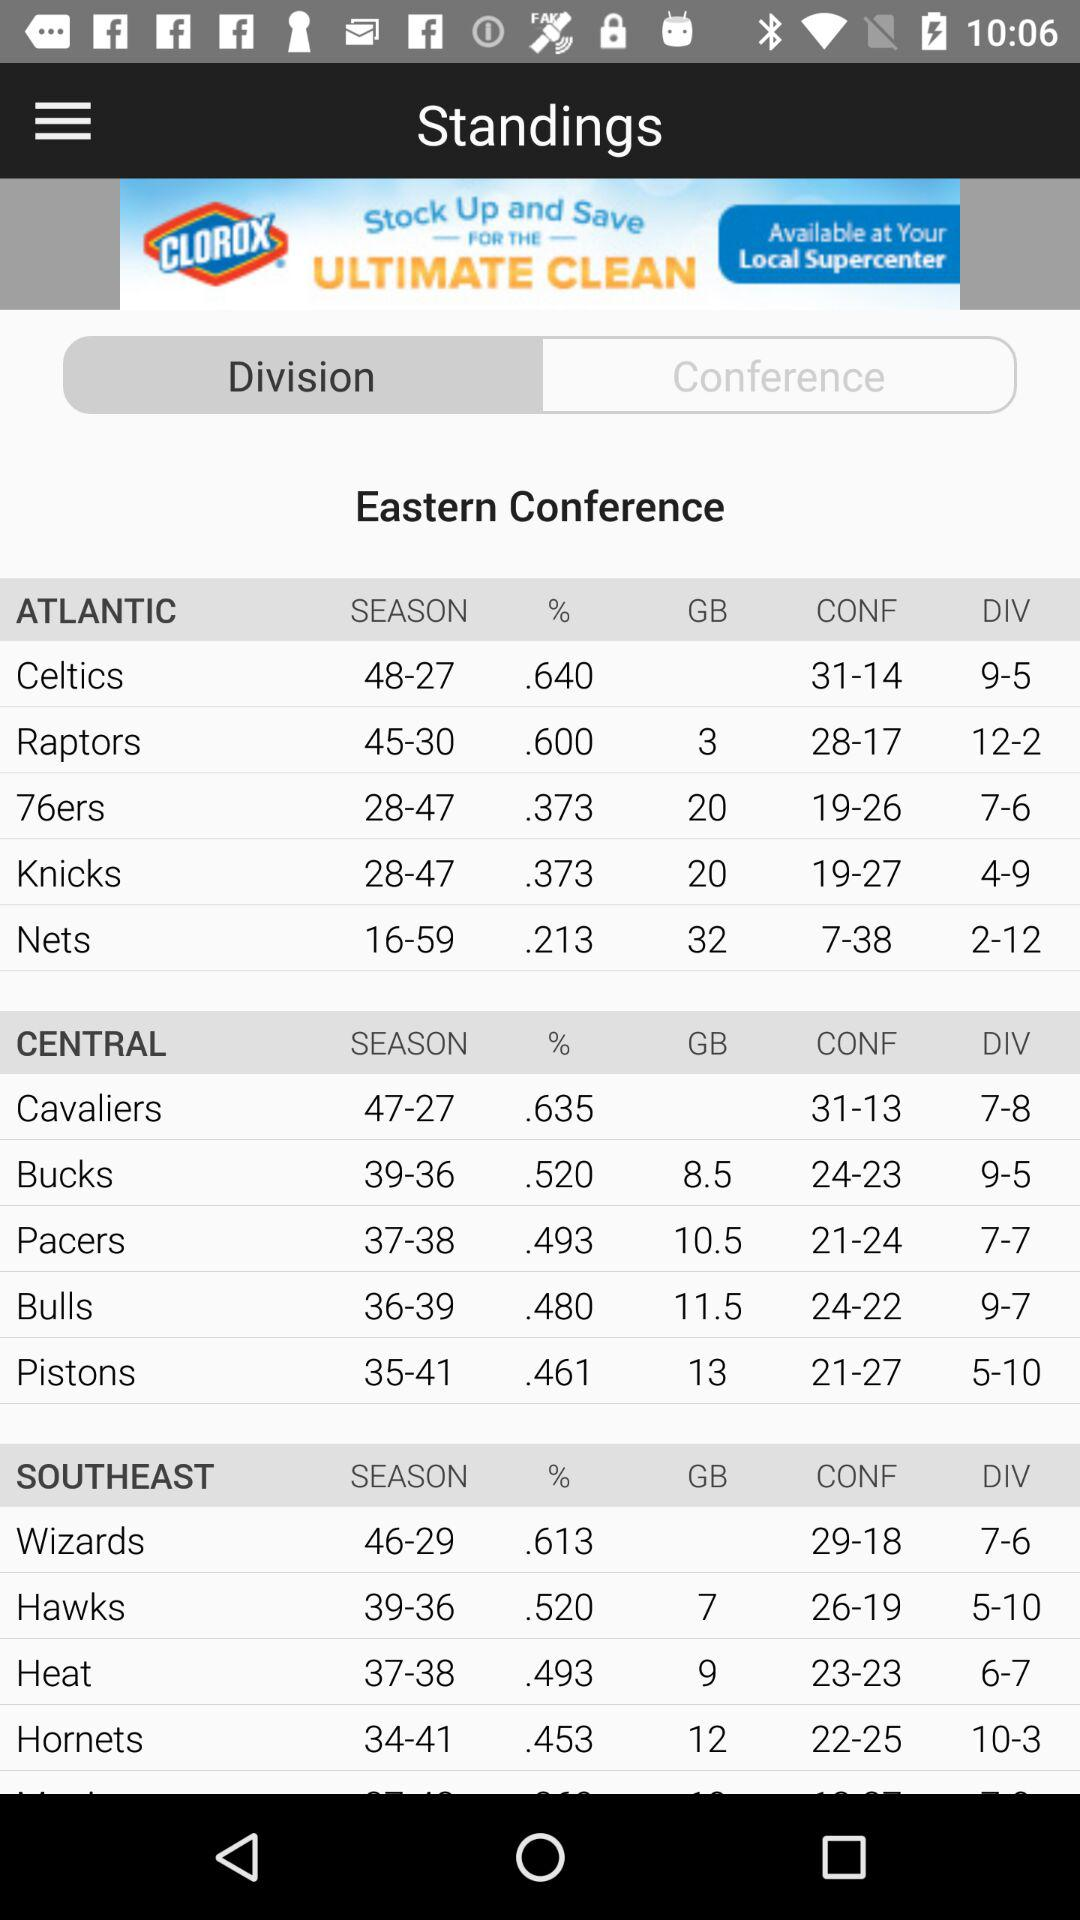Which team has the worst winning percentage, the Nets or the Bulls?
Answer the question using a single word or phrase. Nets 